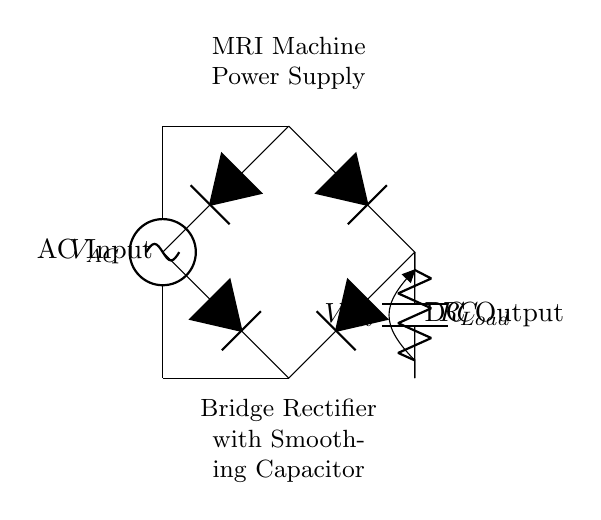What type of rectifier is shown in this circuit? The circuit diagram depicts a bridge rectifier, characterized by four diodes arranged in a bridge configuration. This allows for the conversion of AC voltage to DC voltage effectively.
Answer: bridge rectifier What is the function of the smoothing capacitor in this circuit? The smoothing capacitor serves to reduce the ripple in the DC output voltage after rectification. It charges when the voltage increases and discharges when it decreases, thus providing a more stable DC output.
Answer: stabilize DC output How many diodes are present in the bridge rectifier? There are four diodes used in the bridge rectifier configuration, which are necessary to allow current to flow in both directions from the AC source.
Answer: four What is the role of the load resistor in this circuit? The load resistor is connected to the output of the rectifier and provides a path for the current to flow to the load, allowing it to perform its required function, such as powering a device or circuit.
Answer: provide load path What is the nature of the input voltage applied to the circuit? The input voltage is alternating current (AC), which is necessary for the bridge rectifier to function correctly, as it converts AC to direct current (DC) for the load.
Answer: alternating current Why is a bridge rectifier preferred over a half-wave rectifier for this application? A bridge rectifier is preferred because it utilizes both halves of the AC cycle, resulting in higher efficiency and better voltage regulation output compared to a half-wave rectifier, which only uses one half.
Answer: higher efficiency 